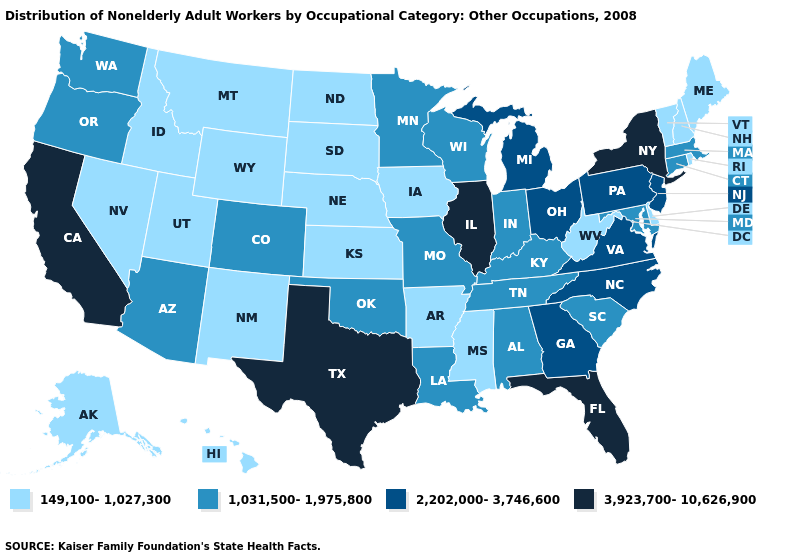What is the value of Idaho?
Short answer required. 149,100-1,027,300. Name the states that have a value in the range 3,923,700-10,626,900?
Short answer required. California, Florida, Illinois, New York, Texas. Does New Jersey have the lowest value in the Northeast?
Keep it brief. No. Name the states that have a value in the range 3,923,700-10,626,900?
Answer briefly. California, Florida, Illinois, New York, Texas. What is the value of Illinois?
Be succinct. 3,923,700-10,626,900. What is the value of Idaho?
Quick response, please. 149,100-1,027,300. Among the states that border Tennessee , does Alabama have the highest value?
Be succinct. No. Among the states that border Alabama , which have the highest value?
Concise answer only. Florida. Name the states that have a value in the range 2,202,000-3,746,600?
Short answer required. Georgia, Michigan, New Jersey, North Carolina, Ohio, Pennsylvania, Virginia. What is the lowest value in the USA?
Answer briefly. 149,100-1,027,300. What is the value of Oklahoma?
Concise answer only. 1,031,500-1,975,800. Does the map have missing data?
Keep it brief. No. Among the states that border Texas , which have the highest value?
Keep it brief. Louisiana, Oklahoma. What is the value of Texas?
Write a very short answer. 3,923,700-10,626,900. 